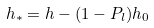Convert formula to latex. <formula><loc_0><loc_0><loc_500><loc_500>h _ { * } = h - ( 1 - P _ { l } ) h _ { 0 }</formula> 